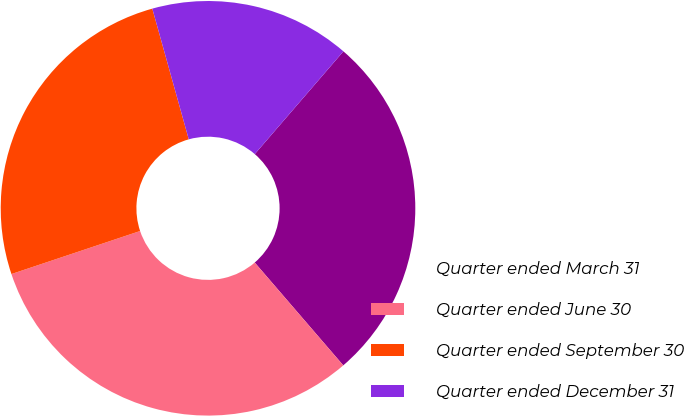Convert chart to OTSL. <chart><loc_0><loc_0><loc_500><loc_500><pie_chart><fcel>Quarter ended March 31<fcel>Quarter ended June 30<fcel>Quarter ended September 30<fcel>Quarter ended December 31<nl><fcel>27.36%<fcel>31.18%<fcel>25.81%<fcel>15.66%<nl></chart> 